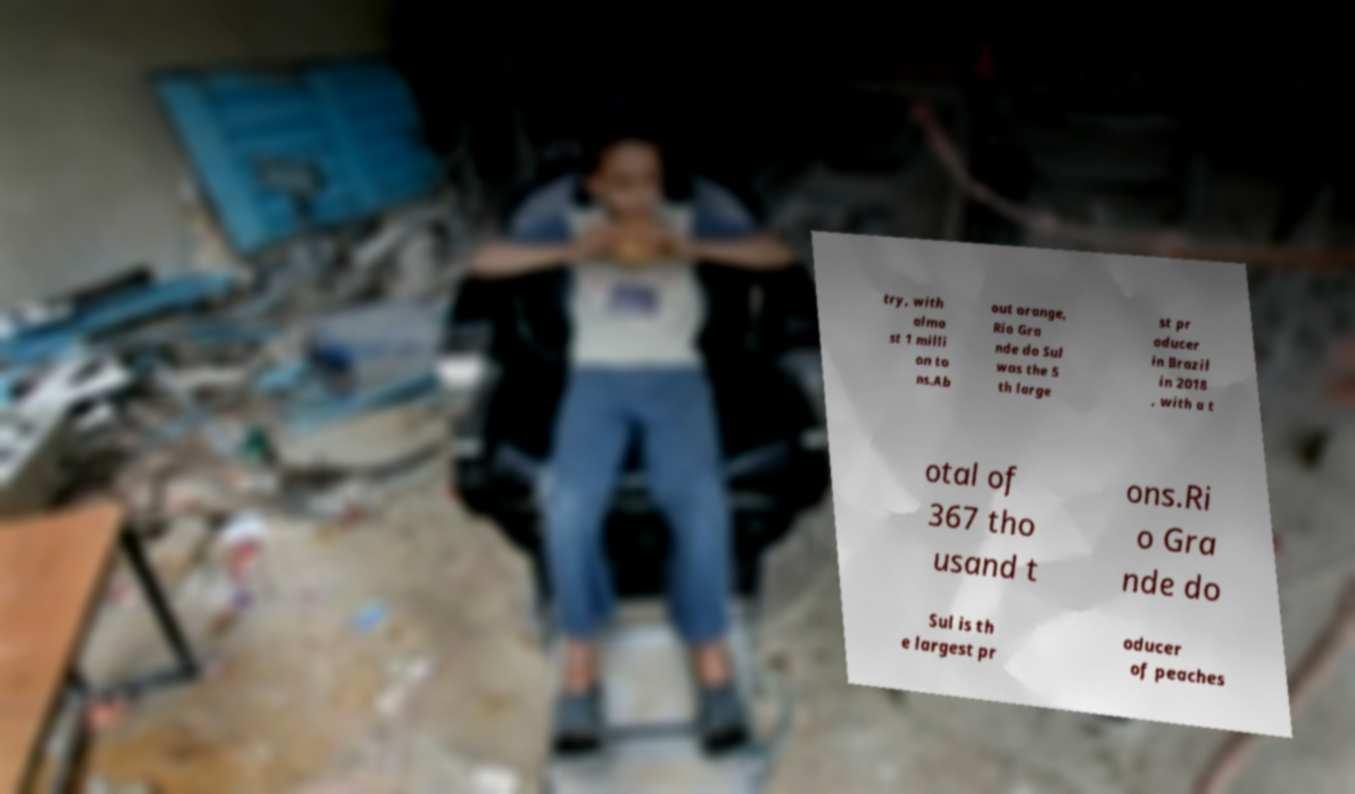Please read and relay the text visible in this image. What does it say? try, with almo st 1 milli on to ns.Ab out orange, Rio Gra nde do Sul was the 5 th large st pr oducer in Brazil in 2018 , with a t otal of 367 tho usand t ons.Ri o Gra nde do Sul is th e largest pr oducer of peaches 